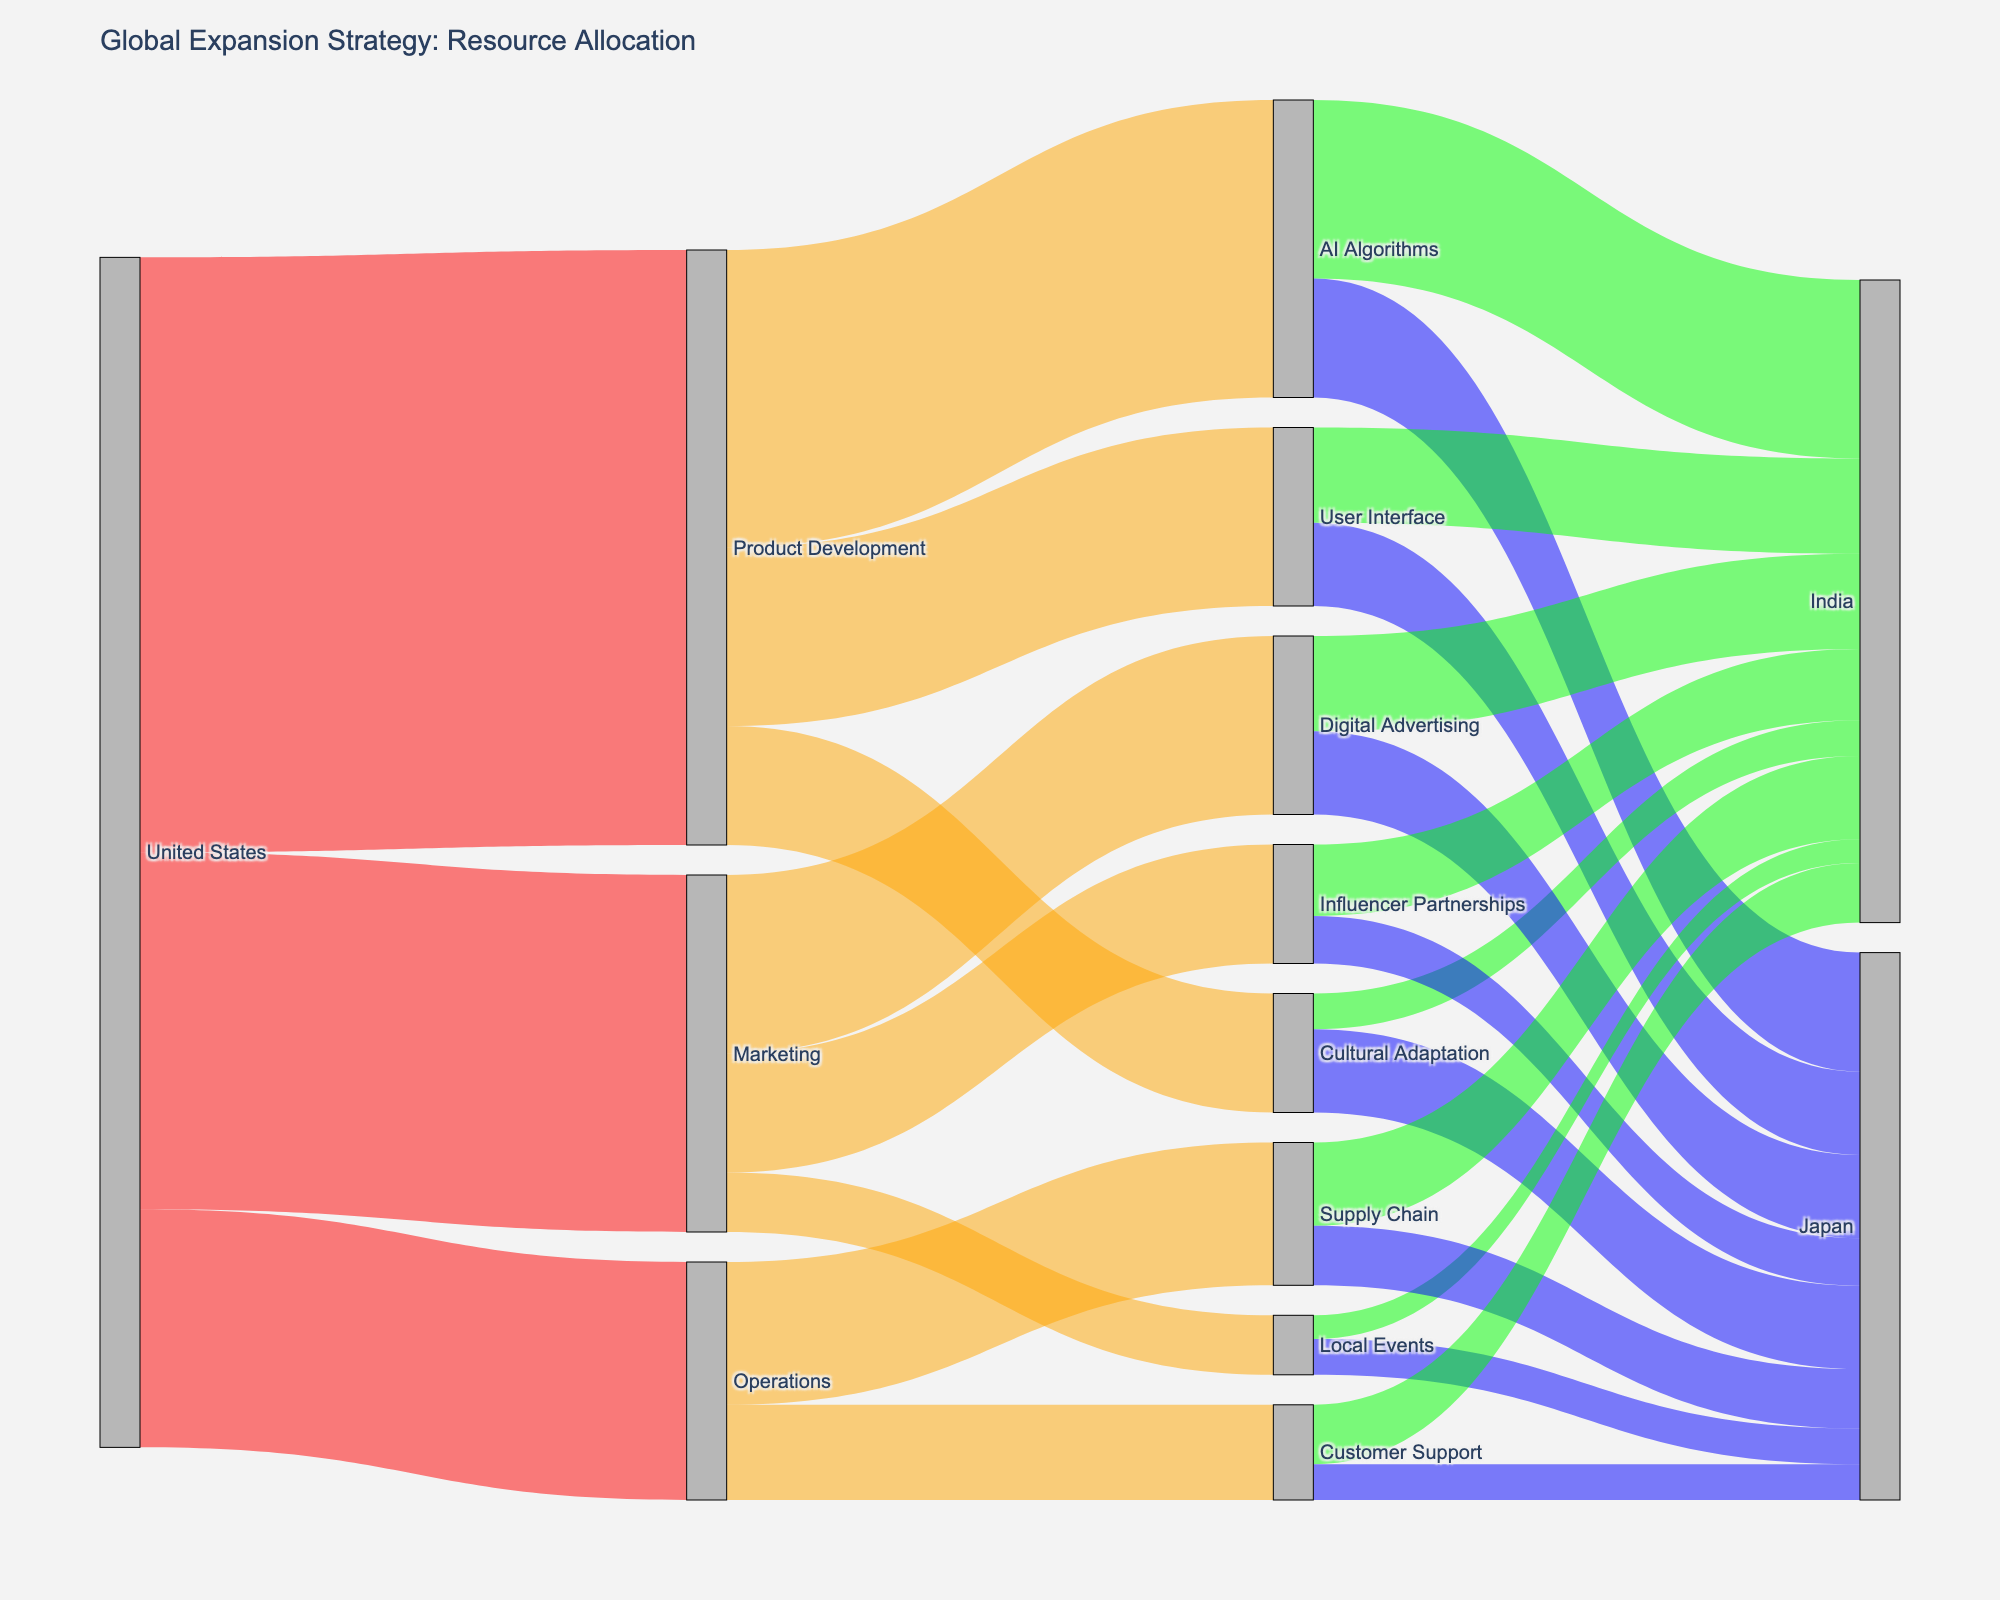What is the title of the Sankey diagram? The title of a graph is usually found at the top and indicates the main focus or topic of the visualization.
Answer: Global Expansion Strategy: Resource Allocation Which target category receives the highest investment from the United States? By examining the flows emanating from the United States node, you can see which target categories have the largest values associated.
Answer: Product Development How much investment is allocated to Marketing from the United States? Look at the value of the flow between the United States node and the Marketing node to determine this amount.
Answer: 30 What is the combined investment in India across all areas? Sum up all the values associated with India as the target across different areas: AI Algorithms (15), User Interface (8), Cultural Adaptation (3), Digital Advertising (8), Influencer Partnerships (6), Local Events (2), Supply Chain (7), Customer Support (5).
Answer: 54 Compare the investments in AI Algorithms between India and Japan. Which country receives more? Look at the values associated with AI Algorithms flowing to India and Japan, then compare these values directly.
Answer: India What is the total investment in Japan across all categories? Sum up all the values flowing to Japan as the target across different areas: AI Algorithms (10), User Interface (7), Cultural Adaptation (7), Digital Advertising (7), Influencer Partnerships (4), Local Events (3), Supply Chain (5), Customer Support (3).
Answer: 46 Which cultural consideration area (Cultural Adaptation) receives more investment, India or Japan? Look at the specific flow for Cultural Adaptation and compare the values for India and Japan.
Answer: Japan What are the three sub-categories that receive investment under Operations? Identify the flows from Operations node to its respective targets.
Answer: Supply Chain, Customer Support How much investment is allocated to User Interface in total? Sum the values flowing to User Interface from Product Development: India (8) and Japan (7).
Answer: 15 Which country receives equal investment in both Local Events and Customer Support? Look at the values of the flows to Local Events and Customer Support for each country and identify which country has equal values.
Answer: Japan 